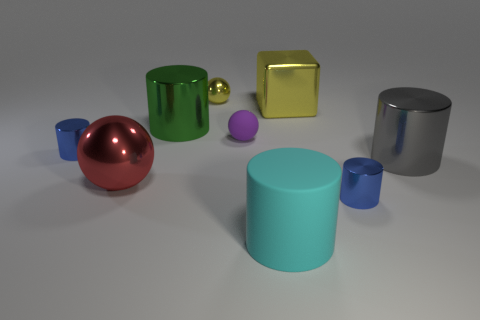Subtract all cyan cylinders. How many cylinders are left? 4 Subtract all cyan cylinders. How many cylinders are left? 4 Subtract all yellow cylinders. Subtract all yellow cubes. How many cylinders are left? 5 Subtract all balls. How many objects are left? 6 Subtract all small green matte balls. Subtract all big gray shiny cylinders. How many objects are left? 8 Add 8 tiny blue cylinders. How many tiny blue cylinders are left? 10 Add 2 green cylinders. How many green cylinders exist? 3 Subtract 0 gray blocks. How many objects are left? 9 